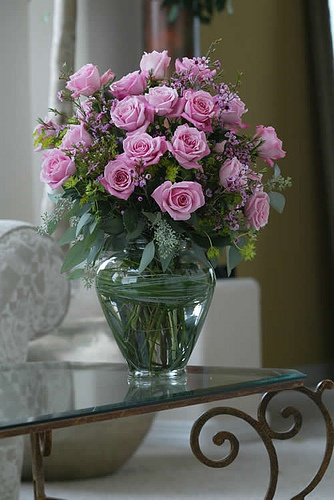Describe the objects in this image and their specific colors. I can see vase in gray, black, teal, and darkgreen tones and couch in gray tones in this image. 